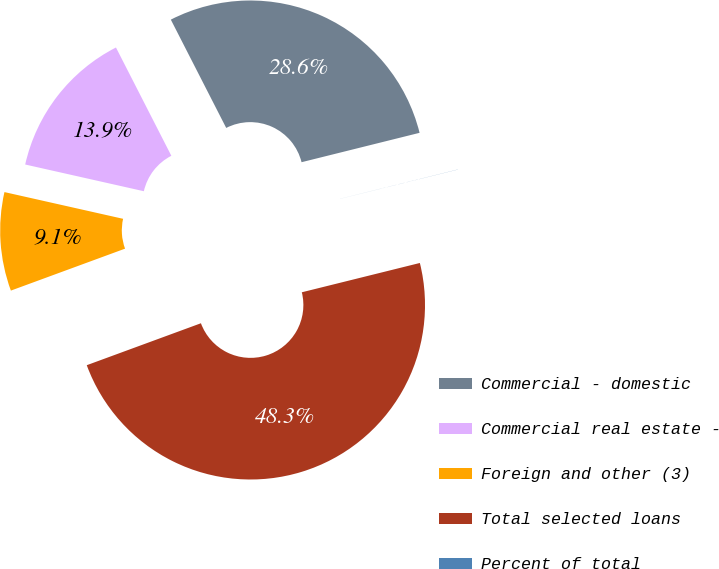<chart> <loc_0><loc_0><loc_500><loc_500><pie_chart><fcel>Commercial - domestic<fcel>Commercial real estate -<fcel>Foreign and other (3)<fcel>Total selected loans<fcel>Percent of total<nl><fcel>28.64%<fcel>13.95%<fcel>9.13%<fcel>48.27%<fcel>0.01%<nl></chart> 